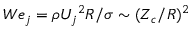<formula> <loc_0><loc_0><loc_500><loc_500>W e _ { j } = \rho { U _ { j } } ^ { 2 } R / \sigma \sim ( Z _ { c } / R ) ^ { 2 }</formula> 